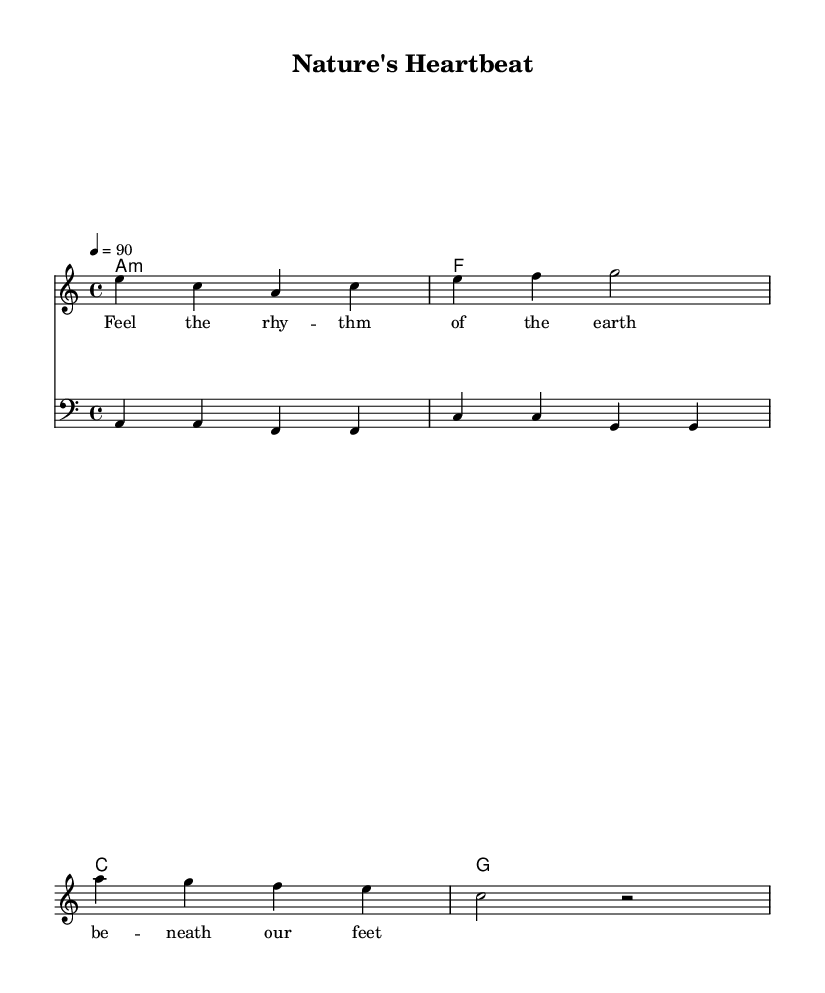What is the key signature of this music? The key signature is A minor, which has no sharps or flats. This can be determined by looking at the part of the sheet music that indicates the key signature, typically found at the beginning of the staff.
Answer: A minor What is the time signature of this music? The time signature is 4/4, indicating that there are four beats in each measure and the quarter note receives one beat. This is indicated at the beginning of the score, near the key signature.
Answer: 4/4 What is the tempo marking for this piece? The tempo marking is quarter note equals 90, meaning the piece should be played at a moderate speed of 90 beats per minute. This can be found written in the score, near the time signature.
Answer: 90 How many measures are there in the melody? The melody consists of 4 measures, which is evident by counting the groupings of notes and rests in the melody section. Each vertical line in the staff represents a measure.
Answer: 4 Which chord is used for the first measure? The chord used for the first measure is A minor, as indicated by the chord symbols above the staff. This requires recognizing the chord symbols in the chord section of the sheet music.
Answer: A minor What is the main theme expressed by the lyrics? The main theme expressed by the lyrics is the connection to nature and rhythm, focusing on the earth beneath our feet. This is determined by reading the lyrical line provided, which encapsulates the overall sentiment of the piece.
Answer: Connection to nature What rhythmic style is emphasized in reggae music? The rhythmic style emphasized in reggae music is offbeat, where the third beat of each measure is often accented. This provides the characteristic reggae feel and can be deduced from the syncopation and laid-back groove commonly used in the melody and harmony sections.
Answer: Offbeat 